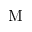<formula> <loc_0><loc_0><loc_500><loc_500>M</formula> 